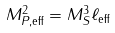Convert formula to latex. <formula><loc_0><loc_0><loc_500><loc_500>M _ { P , \text {eff} } ^ { 2 } = M _ { S } ^ { 3 } \ell _ { \text {eff} }</formula> 